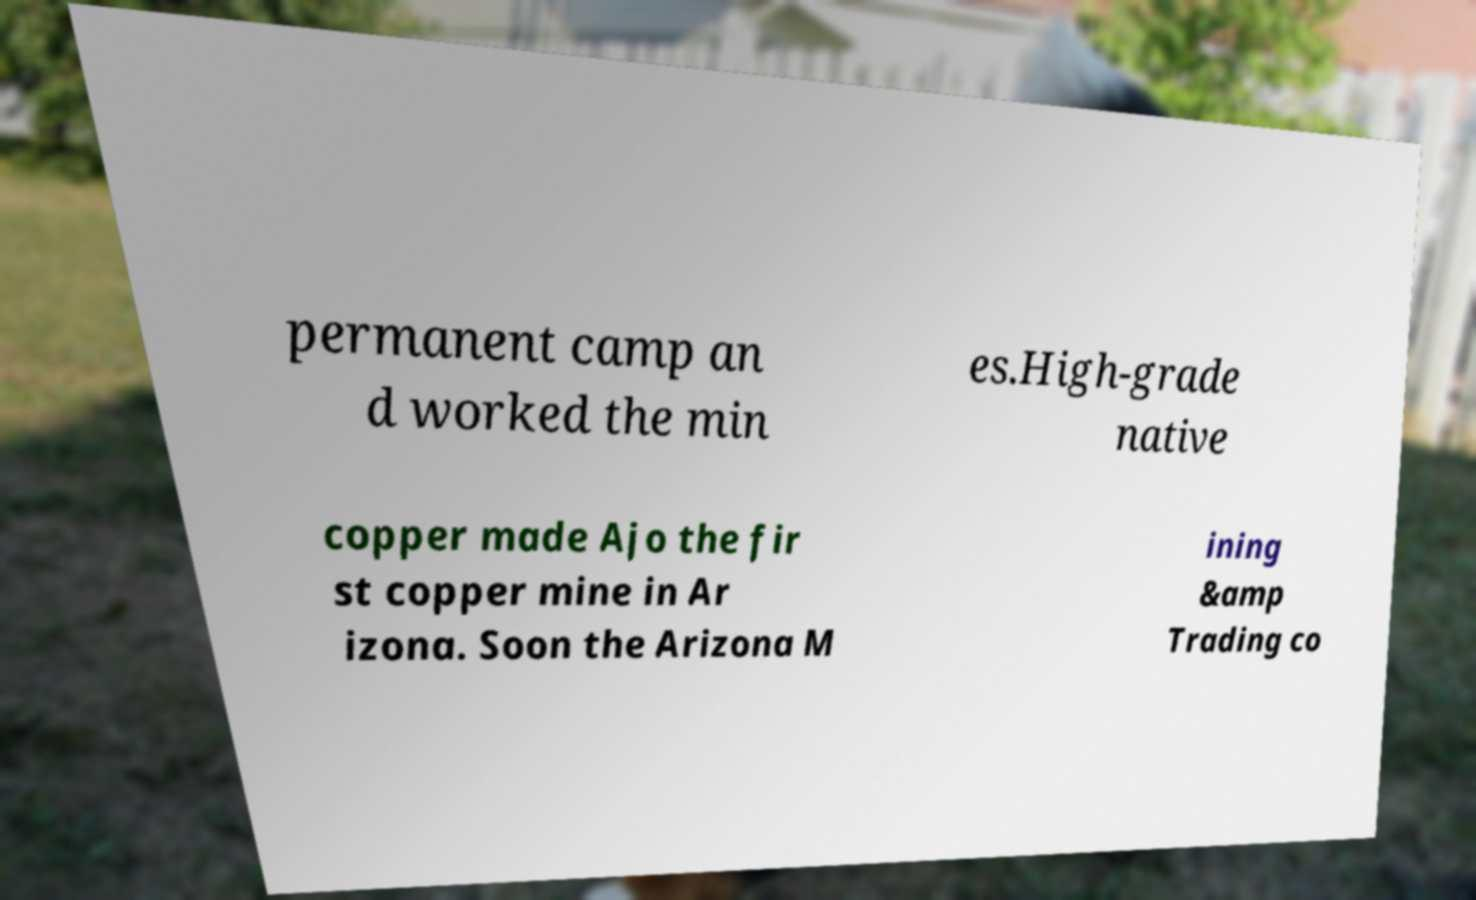There's text embedded in this image that I need extracted. Can you transcribe it verbatim? permanent camp an d worked the min es.High-grade native copper made Ajo the fir st copper mine in Ar izona. Soon the Arizona M ining &amp Trading co 